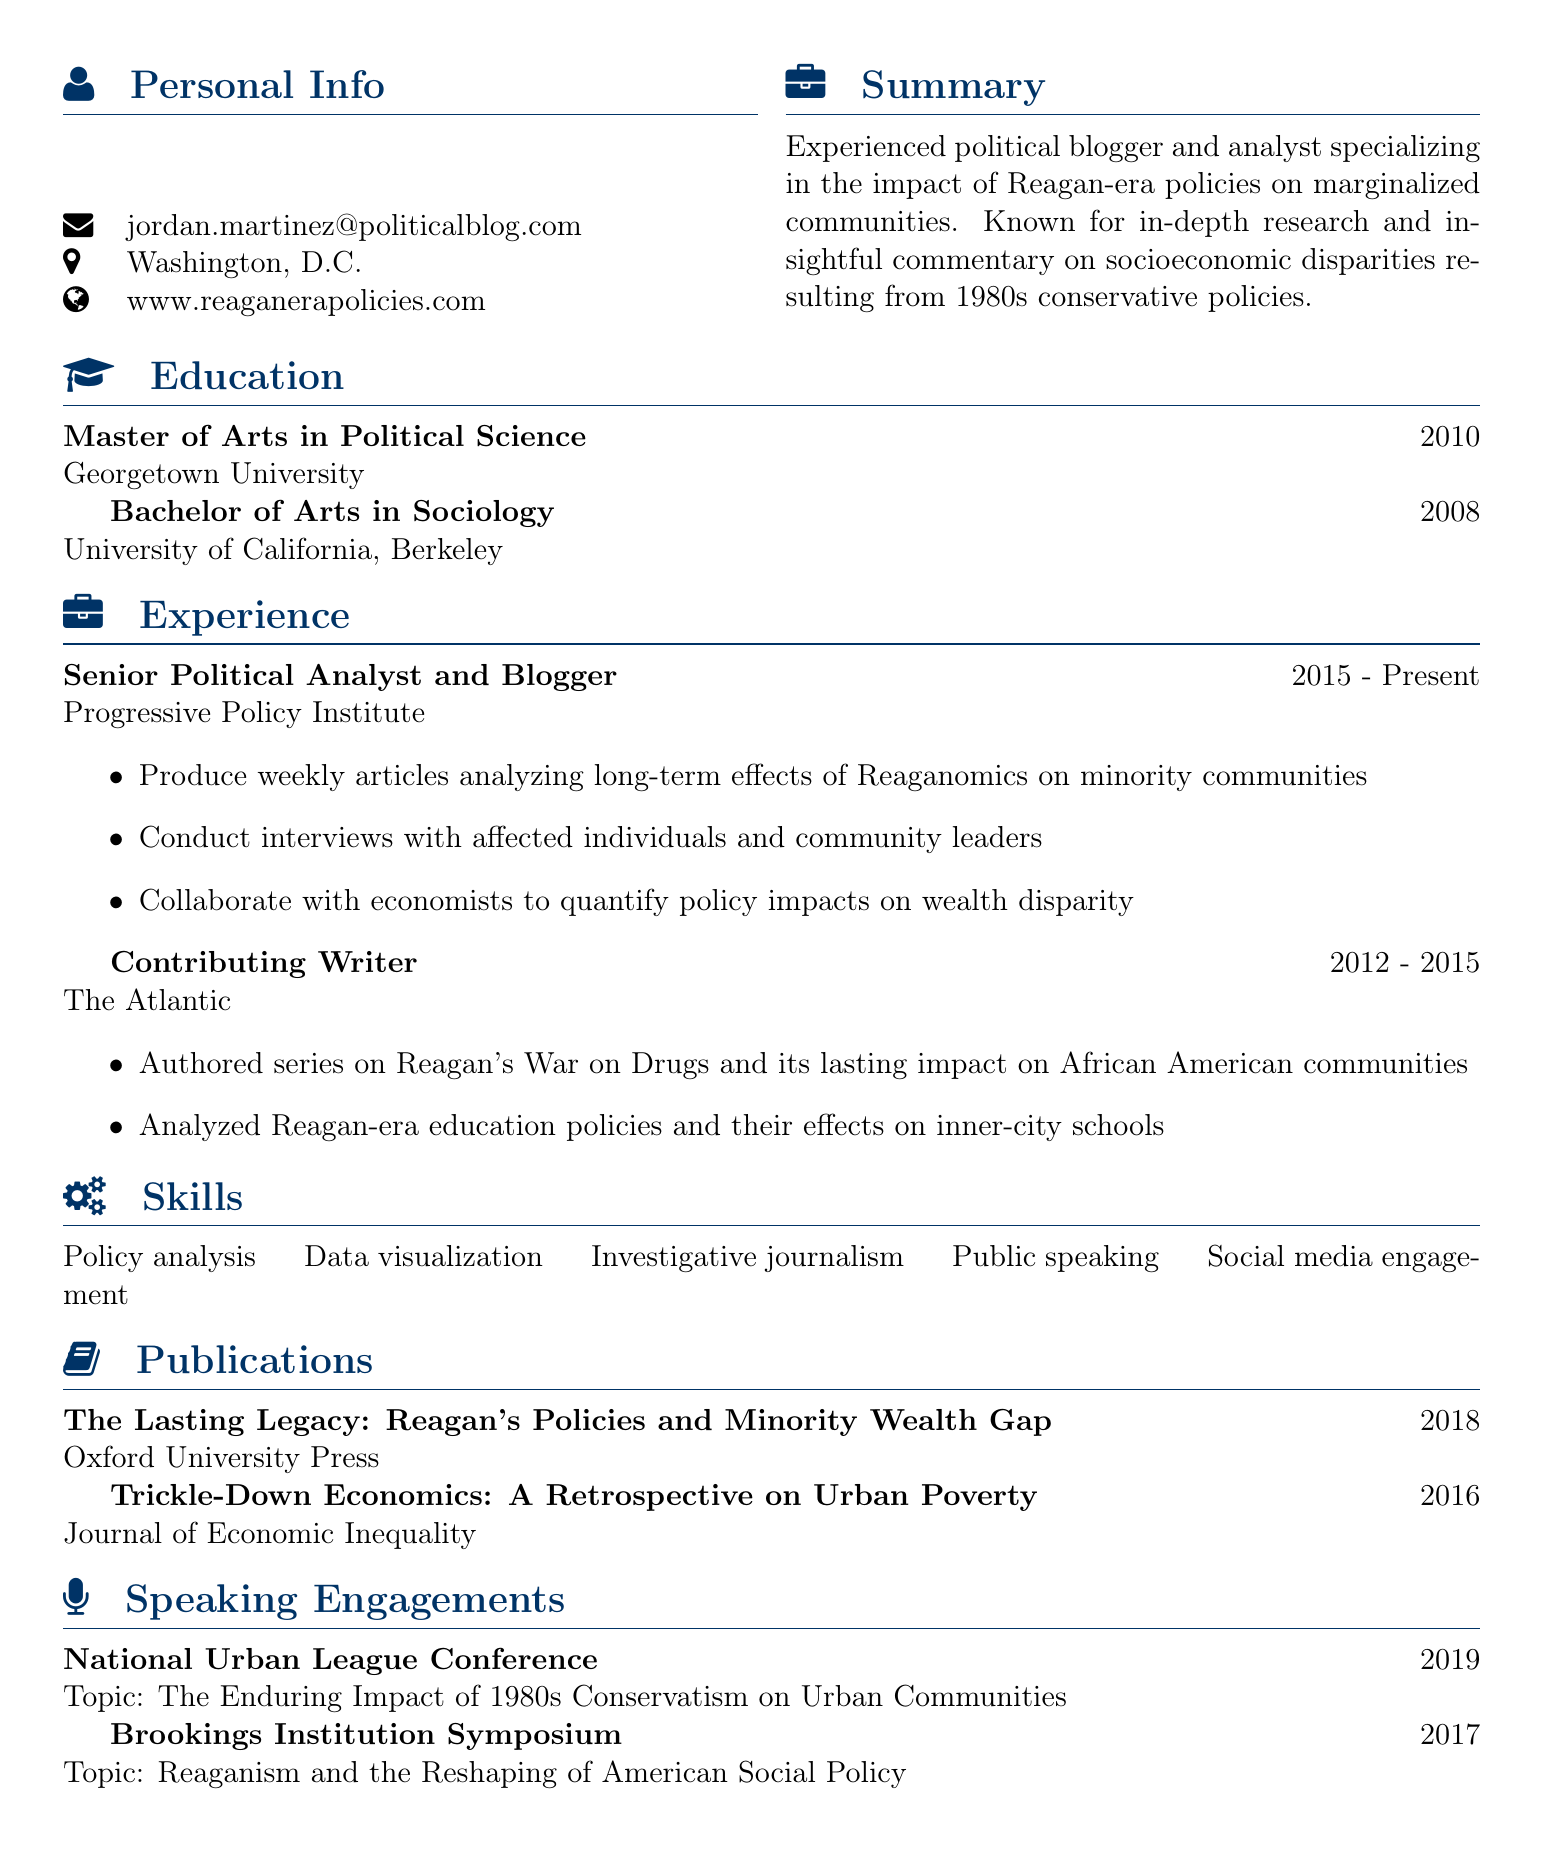what is the name of the political blogger? The name is Jordan Martinez, as stated at the beginning of the document.
Answer: Jordan Martinez which university did Jordan Martinez obtain a Master's degree from? The Master's degree was obtained from Georgetown University, as listed under the education section.
Answer: Georgetown University what is the title of the publication released in 2018? The title of the publication is found under the publications section.
Answer: The Lasting Legacy: Reagan's Policies and Minority Wealth Gap how many years did Jordan Martinez work at The Atlantic? The tenure at The Atlantic is calculated from the duration provided in the experience section, from 2012 to 2015.
Answer: 3 years what topic did Jordan Martinez speak on at the Brookings Institution Symposium? The topic is stated under speaking engagements, detailing the focus of the event.
Answer: Reaganism and the Reshaping of American Social Policy what skills does Jordan Martinez list in the CV? The skills section outlines various competencies that the blogger has.
Answer: Policy analysis, Data visualization, Investigative journalism, Public speaking, Social media engagement when did Jordan Martinez start working at the Progressive Policy Institute? The starting year is given in the experience section.
Answer: 2015 how many publications are listed in the CV? The number of publications is indicated by the entries in the publications section.
Answer: 2 